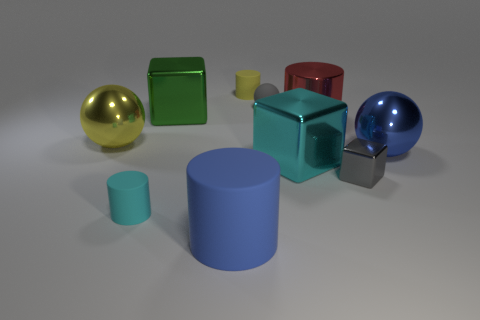How many objects are cubes? There are two objects shaped as cubes in the image: one green and one red. 